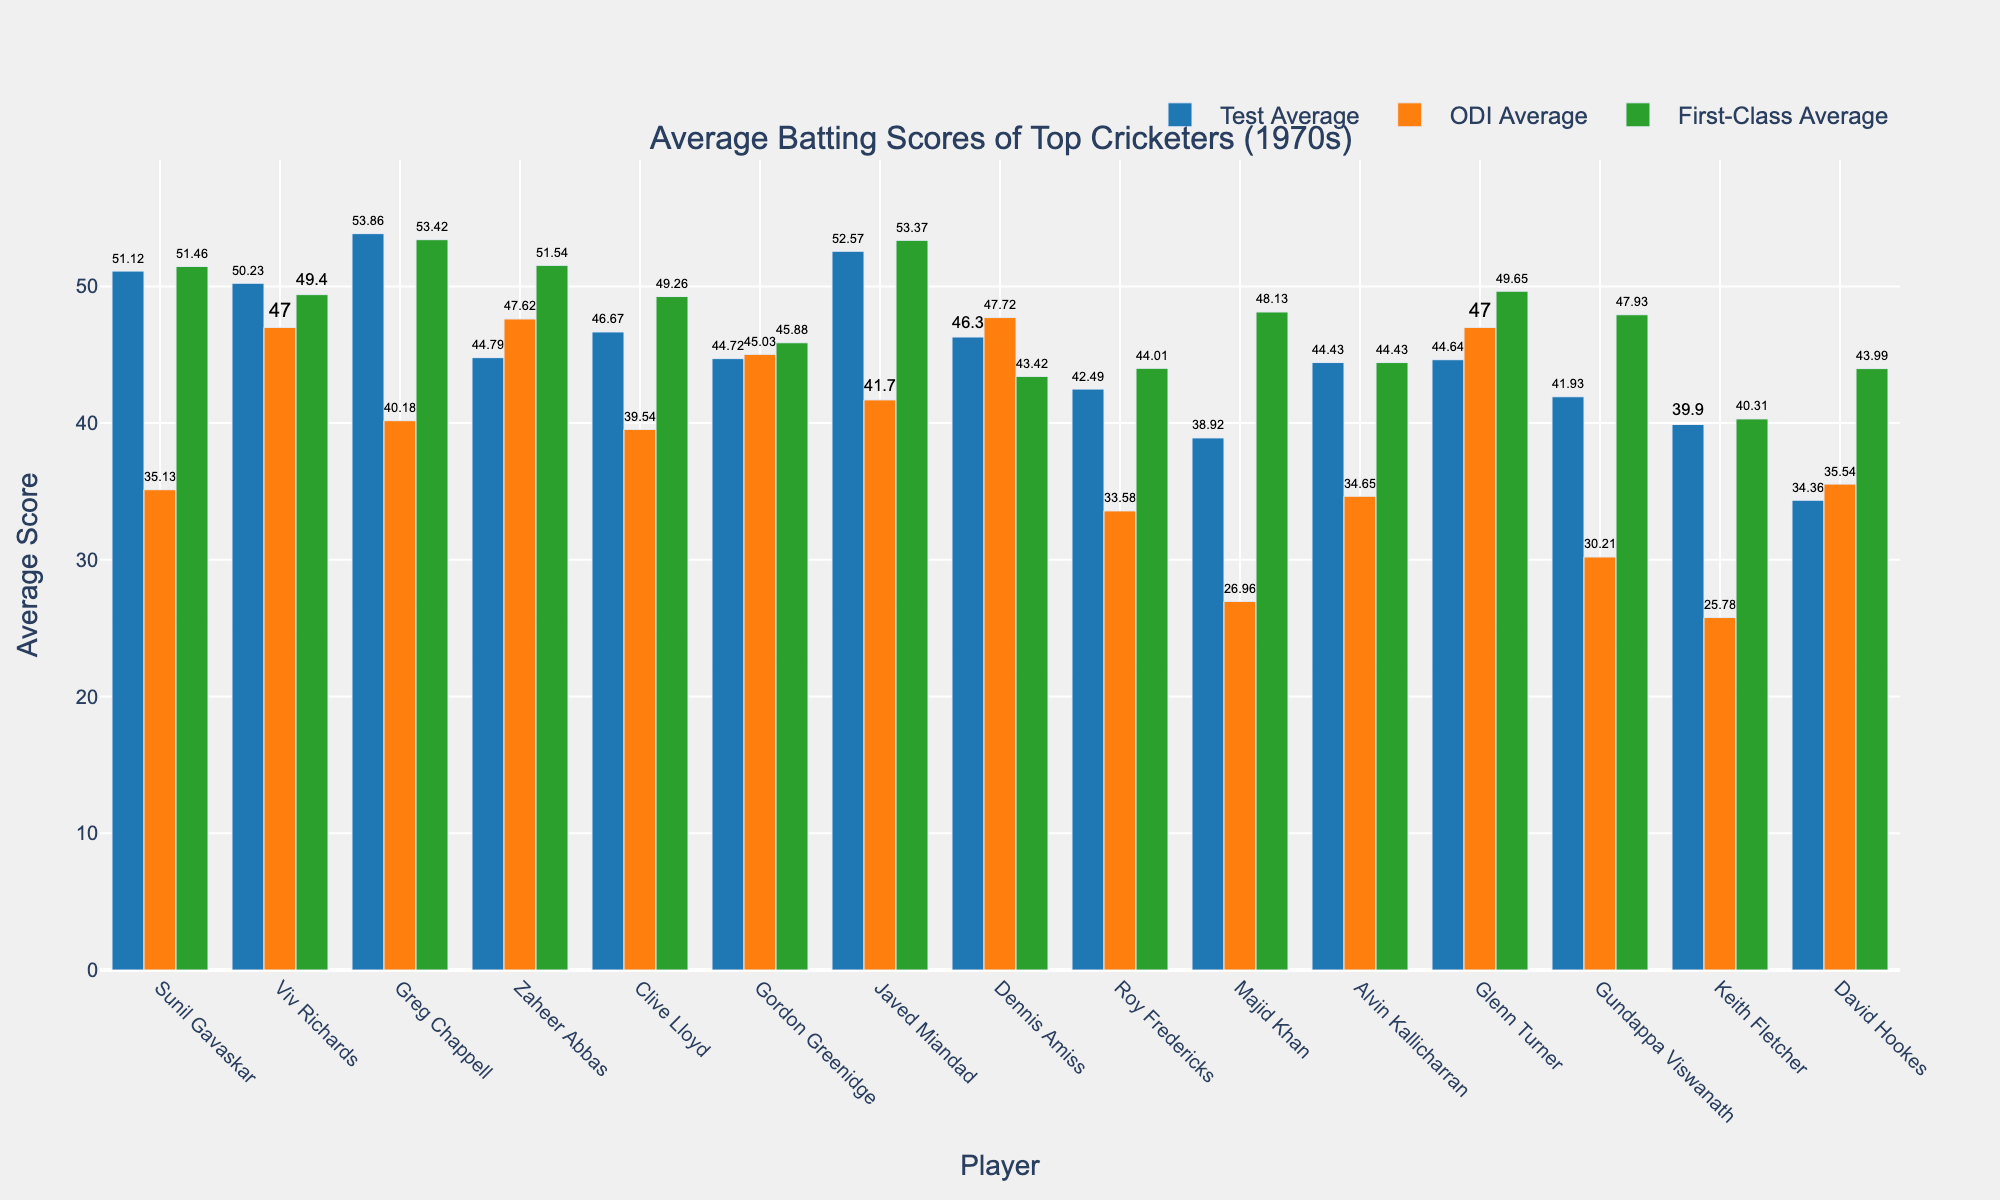What is the average Test score of Sunil Gavaskar? The bar representing Sunil Gavaskar in the Test Average group is marked with a value, which can be directly read. The average Test score for Sunil Gavaskar is explicitly labeled as 51.12.
Answer: 51.12 Which cricketer has the highest One Day International (ODI) average? By comparing the heights of the bars in the ODI Average category, it is clear that Dennis Amiss's bar is the tallest, indicating he has the highest ODI average.
Answer: Dennis Amiss What is the difference between the Test Average and First-Class Average of Javed Miandad? Javed Miandad's Test Average is marked as 52.57, and his First-Class Average is marked as 53.37. The difference can be calculated as 53.37 - 52.57.
Answer: 0.80 Who has a greater First-Class average, Viv Richards or Glenn Turner? Comparing the heights of the bars in the First-Class Average group for Viv Richards and Glenn Turner, Glenn Turner's bar is slightly higher.
Answer: Glenn Turner What is the sum of Test and ODI averages for Clive Lloyd? Clive Lloyd's Test Average is 46.67, and his ODI Average is 39.54. Summing these values gives 46.67 + 39.54.
Answer: 86.21 Which format does Greg Chappell have the lowest batting average in? By comparing the bars for Greg Chappell across Test, ODI, and First-Class categories, his lowest average is seen in the ODI category with a value of 40.18.
Answer: ODI Between Zaheer Abbas and Roy Fredericks, who has a higher average in ODI matches? The heights of the bars in the ODI Average category show that Zaheer Abbas has a notably higher bar compared to Roy Fredericks.
Answer: Zaheer Abbas What is the average First-Class score of Majid Khan? The bar for Majid Khan in the First-Class Average category is marked with a value, which can be directly read as 48.13.
Answer: 48.13 Which cricketer has the lowest Test Average? By examining the heights of all the bars in the Test Average category, it can be seen that David Hookes has the shortest bar, indicating the lowest Test Average.
Answer: David Hookes What is the overall highest batting average (in any format) observed in the dataset? Looking at all the categories, Greg Chappell's Test Average of 53.86 is the highest average observed on the chart.
Answer: 53.86 